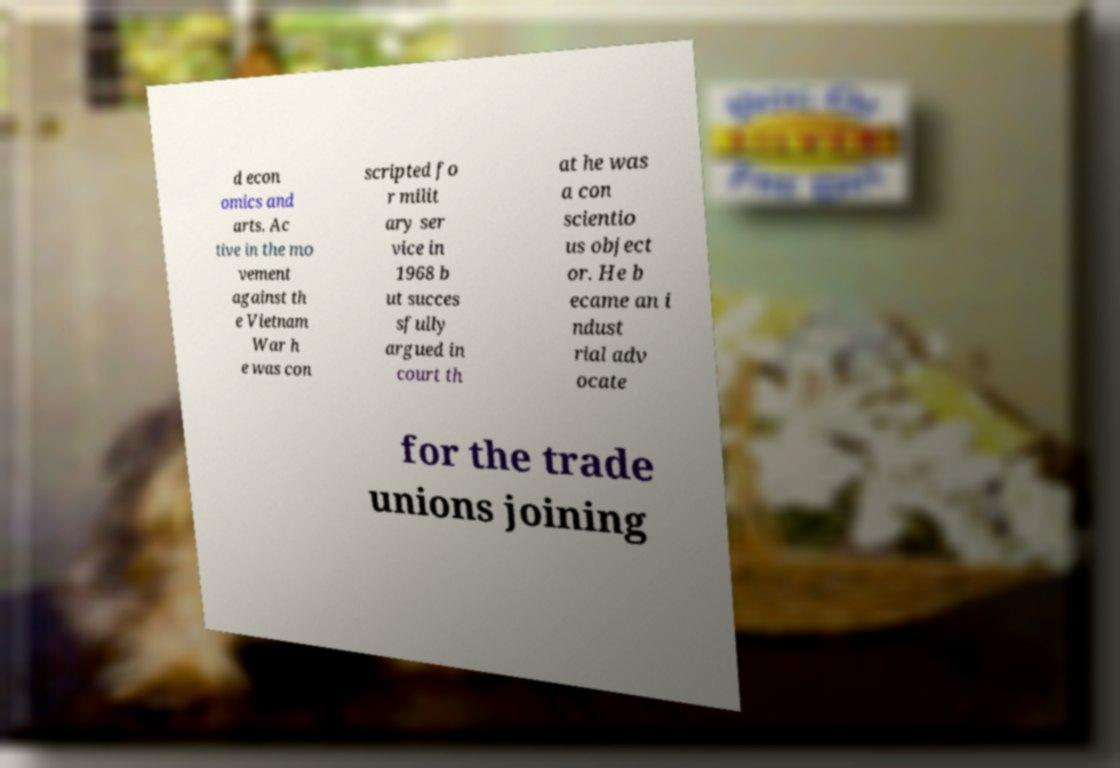What messages or text are displayed in this image? I need them in a readable, typed format. d econ omics and arts. Ac tive in the mo vement against th e Vietnam War h e was con scripted fo r milit ary ser vice in 1968 b ut succes sfully argued in court th at he was a con scientio us object or. He b ecame an i ndust rial adv ocate for the trade unions joining 